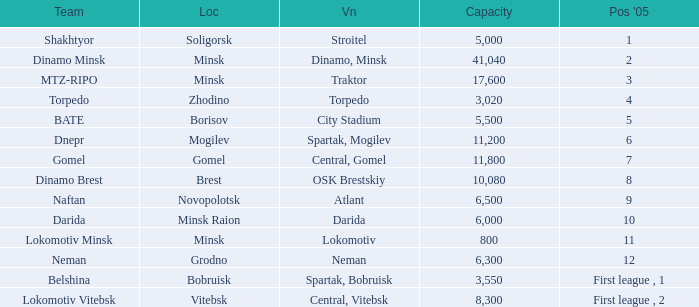Can you give me this table as a dict? {'header': ['Team', 'Loc', 'Vn', 'Capacity', "Pos '05"], 'rows': [['Shakhtyor', 'Soligorsk', 'Stroitel', '5,000', '1'], ['Dinamo Minsk', 'Minsk', 'Dinamo, Minsk', '41,040', '2'], ['MTZ-RIPO', 'Minsk', 'Traktor', '17,600', '3'], ['Torpedo', 'Zhodino', 'Torpedo', '3,020', '4'], ['BATE', 'Borisov', 'City Stadium', '5,500', '5'], ['Dnepr', 'Mogilev', 'Spartak, Mogilev', '11,200', '6'], ['Gomel', 'Gomel', 'Central, Gomel', '11,800', '7'], ['Dinamo Brest', 'Brest', 'OSK Brestskiy', '10,080', '8'], ['Naftan', 'Novopolotsk', 'Atlant', '6,500', '9'], ['Darida', 'Minsk Raion', 'Darida', '6,000', '10'], ['Lokomotiv Minsk', 'Minsk', 'Lokomotiv', '800', '11'], ['Neman', 'Grodno', 'Neman', '6,300', '12'], ['Belshina', 'Bobruisk', 'Spartak, Bobruisk', '3,550', 'First league , 1'], ['Lokomotiv Vitebsk', 'Vitebsk', 'Central, Vitebsk', '8,300', 'First league , 2']]} Can you tell me the highest Capacity that has the Team of torpedo? 3020.0. 